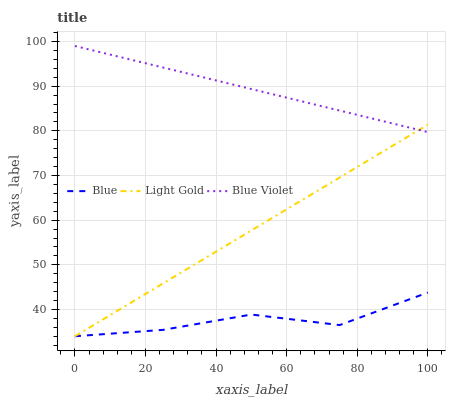Does Light Gold have the minimum area under the curve?
Answer yes or no. No. Does Light Gold have the maximum area under the curve?
Answer yes or no. No. Is Blue Violet the smoothest?
Answer yes or no. No. Is Blue Violet the roughest?
Answer yes or no. No. Does Blue Violet have the lowest value?
Answer yes or no. No. Does Light Gold have the highest value?
Answer yes or no. No. Is Blue less than Blue Violet?
Answer yes or no. Yes. Is Blue Violet greater than Blue?
Answer yes or no. Yes. Does Blue intersect Blue Violet?
Answer yes or no. No. 